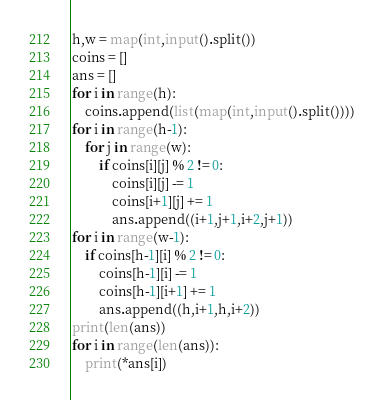Convert code to text. <code><loc_0><loc_0><loc_500><loc_500><_Python_>h,w = map(int,input().split())
coins = []
ans = []
for i in range(h):
    coins.append(list(map(int,input().split())))
for i in range(h-1):
    for j in range(w):
        if coins[i][j] % 2 != 0:
            coins[i][j] -= 1
            coins[i+1][j] += 1
            ans.append((i+1,j+1,i+2,j+1))
for i in range(w-1):
    if coins[h-1][i] % 2 != 0:
        coins[h-1][i] -= 1
        coins[h-1][i+1] += 1
        ans.append((h,i+1,h,i+2))
print(len(ans))
for i in range(len(ans)):
    print(*ans[i])

</code> 